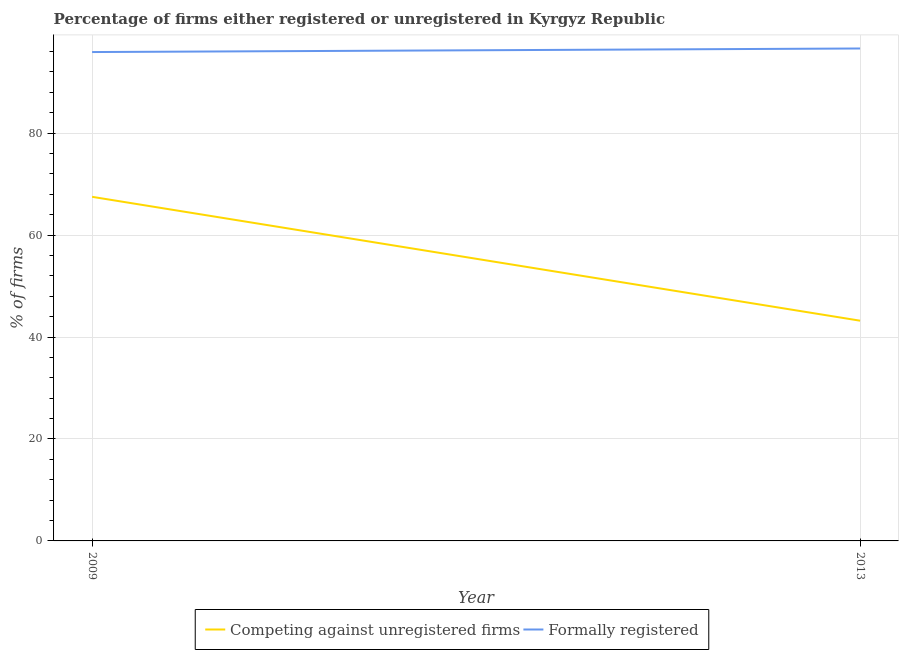How many different coloured lines are there?
Provide a succinct answer. 2. Does the line corresponding to percentage of registered firms intersect with the line corresponding to percentage of formally registered firms?
Ensure brevity in your answer.  No. Is the number of lines equal to the number of legend labels?
Offer a terse response. Yes. What is the percentage of registered firms in 2013?
Keep it short and to the point. 43.2. Across all years, what is the maximum percentage of formally registered firms?
Provide a succinct answer. 96.6. Across all years, what is the minimum percentage of registered firms?
Keep it short and to the point. 43.2. What is the total percentage of registered firms in the graph?
Provide a short and direct response. 110.7. What is the difference between the percentage of formally registered firms in 2009 and that in 2013?
Provide a succinct answer. -0.7. What is the difference between the percentage of formally registered firms in 2009 and the percentage of registered firms in 2013?
Keep it short and to the point. 52.7. What is the average percentage of registered firms per year?
Offer a terse response. 55.35. In the year 2009, what is the difference between the percentage of formally registered firms and percentage of registered firms?
Your answer should be very brief. 28.4. What is the ratio of the percentage of registered firms in 2009 to that in 2013?
Your answer should be very brief. 1.56. In how many years, is the percentage of formally registered firms greater than the average percentage of formally registered firms taken over all years?
Provide a succinct answer. 1. Is the percentage of registered firms strictly greater than the percentage of formally registered firms over the years?
Make the answer very short. No. Is the percentage of registered firms strictly less than the percentage of formally registered firms over the years?
Give a very brief answer. Yes. How many years are there in the graph?
Provide a succinct answer. 2. What is the difference between two consecutive major ticks on the Y-axis?
Keep it short and to the point. 20. Are the values on the major ticks of Y-axis written in scientific E-notation?
Your response must be concise. No. Does the graph contain grids?
Ensure brevity in your answer.  Yes. How many legend labels are there?
Provide a succinct answer. 2. How are the legend labels stacked?
Offer a very short reply. Horizontal. What is the title of the graph?
Make the answer very short. Percentage of firms either registered or unregistered in Kyrgyz Republic. Does "Arms imports" appear as one of the legend labels in the graph?
Your answer should be very brief. No. What is the label or title of the Y-axis?
Keep it short and to the point. % of firms. What is the % of firms in Competing against unregistered firms in 2009?
Ensure brevity in your answer.  67.5. What is the % of firms of Formally registered in 2009?
Your answer should be compact. 95.9. What is the % of firms in Competing against unregistered firms in 2013?
Your answer should be compact. 43.2. What is the % of firms of Formally registered in 2013?
Provide a succinct answer. 96.6. Across all years, what is the maximum % of firms of Competing against unregistered firms?
Offer a terse response. 67.5. Across all years, what is the maximum % of firms of Formally registered?
Your response must be concise. 96.6. Across all years, what is the minimum % of firms of Competing against unregistered firms?
Provide a short and direct response. 43.2. Across all years, what is the minimum % of firms of Formally registered?
Offer a very short reply. 95.9. What is the total % of firms of Competing against unregistered firms in the graph?
Make the answer very short. 110.7. What is the total % of firms of Formally registered in the graph?
Provide a succinct answer. 192.5. What is the difference between the % of firms of Competing against unregistered firms in 2009 and that in 2013?
Give a very brief answer. 24.3. What is the difference between the % of firms of Competing against unregistered firms in 2009 and the % of firms of Formally registered in 2013?
Your answer should be compact. -29.1. What is the average % of firms of Competing against unregistered firms per year?
Make the answer very short. 55.35. What is the average % of firms of Formally registered per year?
Your response must be concise. 96.25. In the year 2009, what is the difference between the % of firms of Competing against unregistered firms and % of firms of Formally registered?
Ensure brevity in your answer.  -28.4. In the year 2013, what is the difference between the % of firms of Competing against unregistered firms and % of firms of Formally registered?
Offer a terse response. -53.4. What is the ratio of the % of firms of Competing against unregistered firms in 2009 to that in 2013?
Your answer should be very brief. 1.56. What is the difference between the highest and the second highest % of firms in Competing against unregistered firms?
Offer a terse response. 24.3. What is the difference between the highest and the second highest % of firms of Formally registered?
Keep it short and to the point. 0.7. What is the difference between the highest and the lowest % of firms of Competing against unregistered firms?
Offer a terse response. 24.3. 